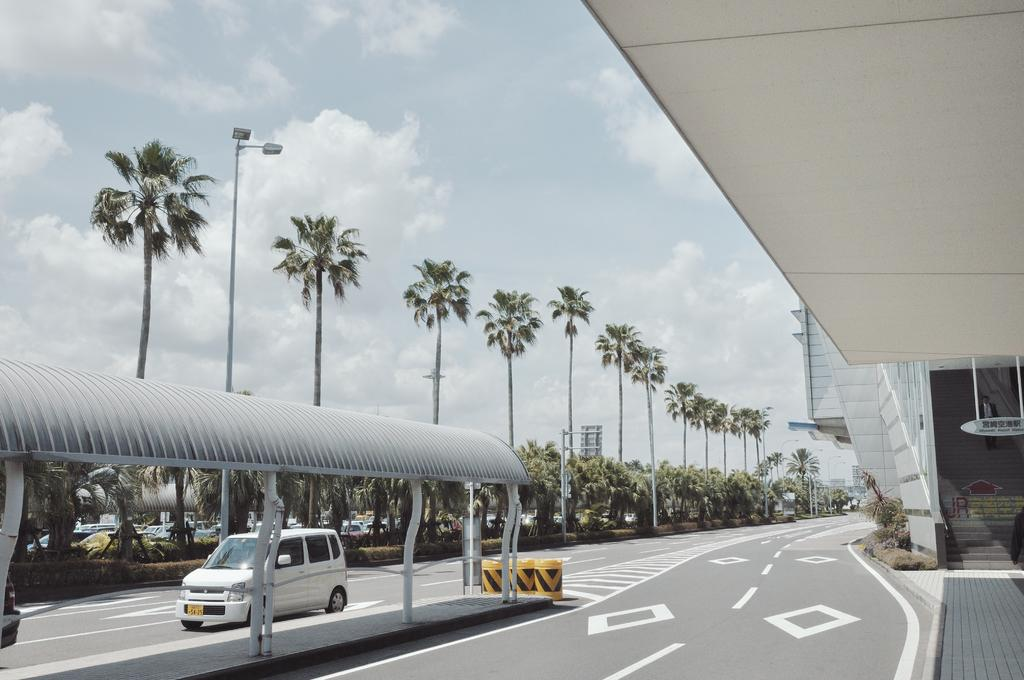What can be seen on the road in the image? There are vehicles on the road in the image. What type of structure can be seen in the image? There is a shed in the image. What type of vegetation is present in the image? There are plants and trees in the image. What type of illumination is present in the image? There are lights in the image. What type of support structures are present in the image? There are poles in the image. What type of man-made structures are present in the image? There are buildings in the image. What can be seen in the background of the image? The sky is visible in the background of the image. Can you see a badge on any of the vehicles in the image? There is no mention of a badge on any of the vehicles in the image. How many elbows are visible in the image? There are no elbows visible in the image, as it features vehicles, a shed, plants, trees, lights, poles, buildings, and the sky. 